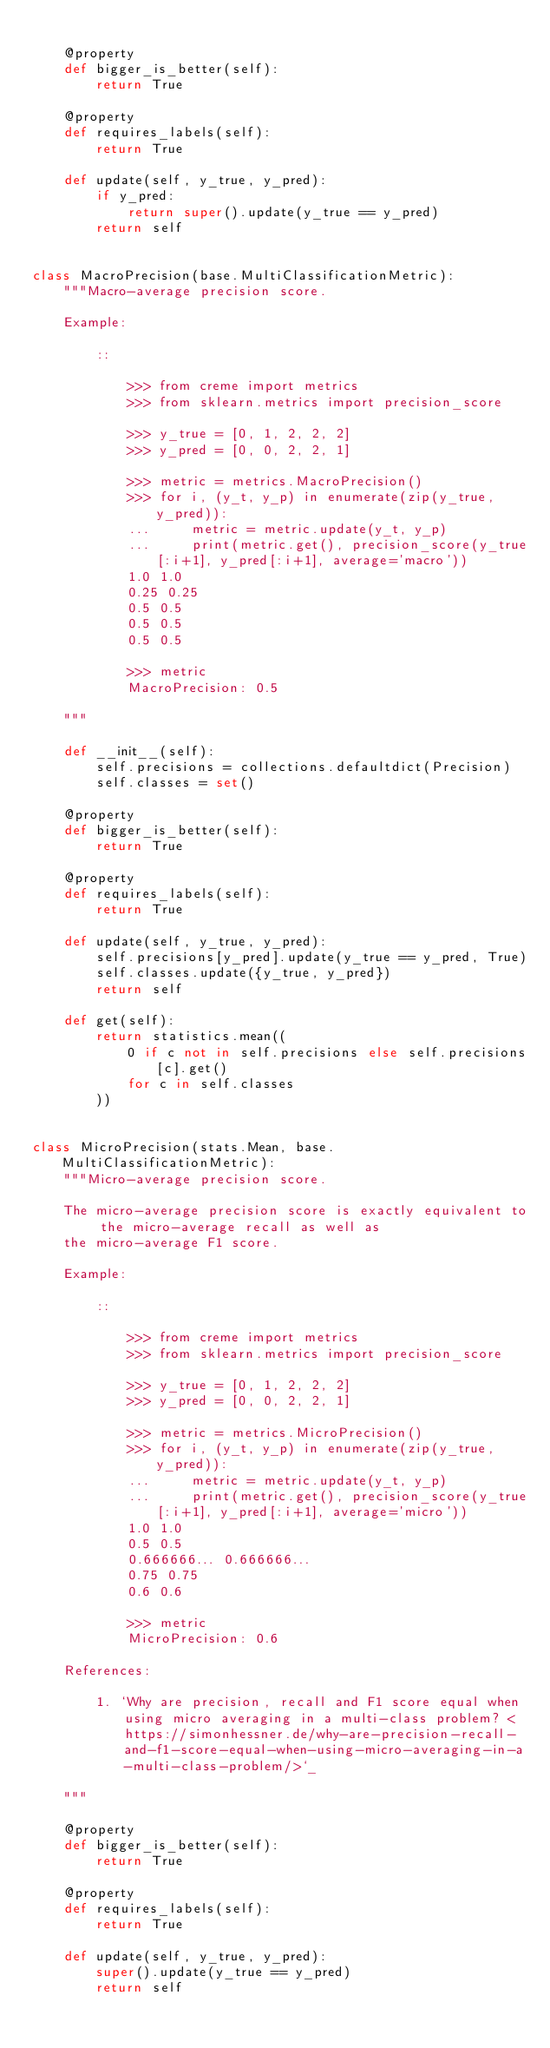Convert code to text. <code><loc_0><loc_0><loc_500><loc_500><_Python_>
    @property
    def bigger_is_better(self):
        return True

    @property
    def requires_labels(self):
        return True

    def update(self, y_true, y_pred):
        if y_pred:
            return super().update(y_true == y_pred)
        return self


class MacroPrecision(base.MultiClassificationMetric):
    """Macro-average precision score.

    Example:

        ::

            >>> from creme import metrics
            >>> from sklearn.metrics import precision_score

            >>> y_true = [0, 1, 2, 2, 2]
            >>> y_pred = [0, 0, 2, 2, 1]

            >>> metric = metrics.MacroPrecision()
            >>> for i, (y_t, y_p) in enumerate(zip(y_true, y_pred)):
            ...     metric = metric.update(y_t, y_p)
            ...     print(metric.get(), precision_score(y_true[:i+1], y_pred[:i+1], average='macro'))
            1.0 1.0
            0.25 0.25
            0.5 0.5
            0.5 0.5
            0.5 0.5

            >>> metric
            MacroPrecision: 0.5

    """

    def __init__(self):
        self.precisions = collections.defaultdict(Precision)
        self.classes = set()

    @property
    def bigger_is_better(self):
        return True

    @property
    def requires_labels(self):
        return True

    def update(self, y_true, y_pred):
        self.precisions[y_pred].update(y_true == y_pred, True)
        self.classes.update({y_true, y_pred})
        return self

    def get(self):
        return statistics.mean((
            0 if c not in self.precisions else self.precisions[c].get()
            for c in self.classes
        ))


class MicroPrecision(stats.Mean, base.MultiClassificationMetric):
    """Micro-average precision score.

    The micro-average precision score is exactly equivalent to the micro-average recall as well as
    the micro-average F1 score.

    Example:

        ::

            >>> from creme import metrics
            >>> from sklearn.metrics import precision_score

            >>> y_true = [0, 1, 2, 2, 2]
            >>> y_pred = [0, 0, 2, 2, 1]

            >>> metric = metrics.MicroPrecision()
            >>> for i, (y_t, y_p) in enumerate(zip(y_true, y_pred)):
            ...     metric = metric.update(y_t, y_p)
            ...     print(metric.get(), precision_score(y_true[:i+1], y_pred[:i+1], average='micro'))
            1.0 1.0
            0.5 0.5
            0.666666... 0.666666...
            0.75 0.75
            0.6 0.6

            >>> metric
            MicroPrecision: 0.6

    References:

        1. `Why are precision, recall and F1 score equal when using micro averaging in a multi-class problem? <https://simonhessner.de/why-are-precision-recall-and-f1-score-equal-when-using-micro-averaging-in-a-multi-class-problem/>`_

    """

    @property
    def bigger_is_better(self):
        return True

    @property
    def requires_labels(self):
        return True

    def update(self, y_true, y_pred):
        super().update(y_true == y_pred)
        return self
</code> 